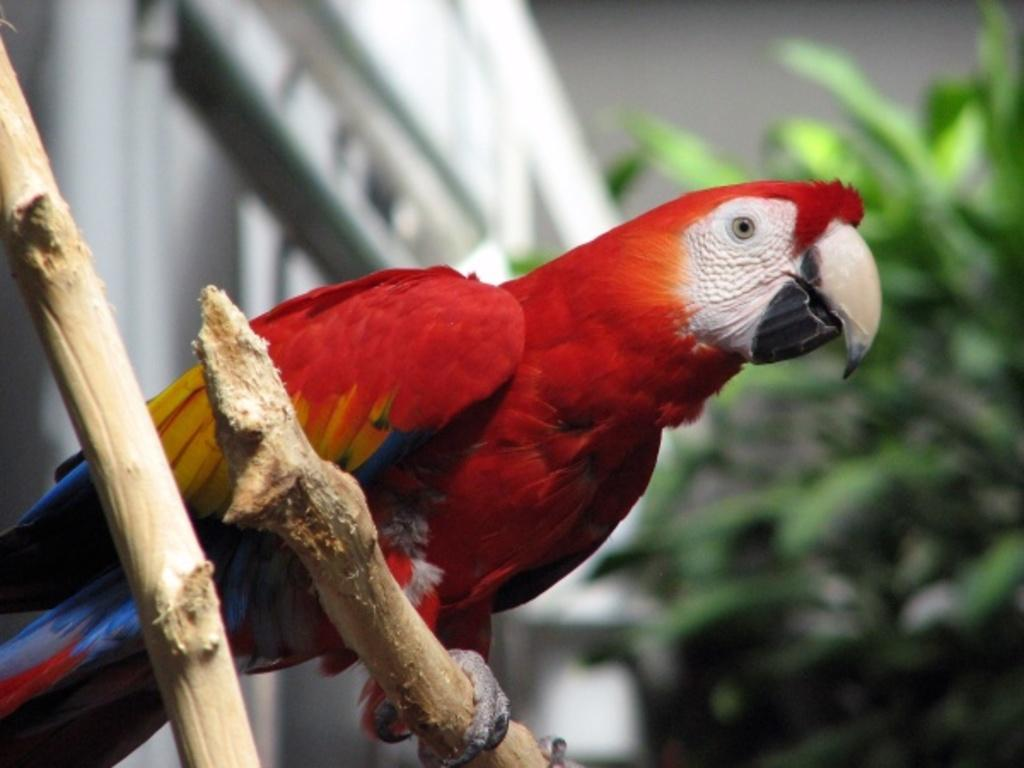What type of animal is in the image? There is a parrot in the image. Where is the parrot located? The parrot is on a branch of a tree. What can be seen in the background of the image? There is a tree and a building in the background of the image. What type of dress is the parrot wearing in the image? There is no dress present in the image, as parrots do not wear clothing. 